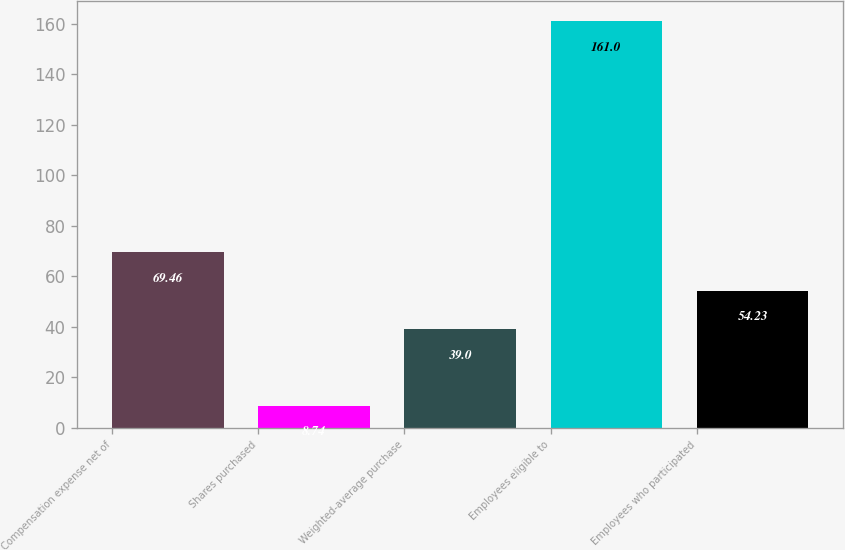<chart> <loc_0><loc_0><loc_500><loc_500><bar_chart><fcel>Compensation expense net of<fcel>Shares purchased<fcel>Weighted-average purchase<fcel>Employees eligible to<fcel>Employees who participated<nl><fcel>69.46<fcel>8.74<fcel>39<fcel>161<fcel>54.23<nl></chart> 